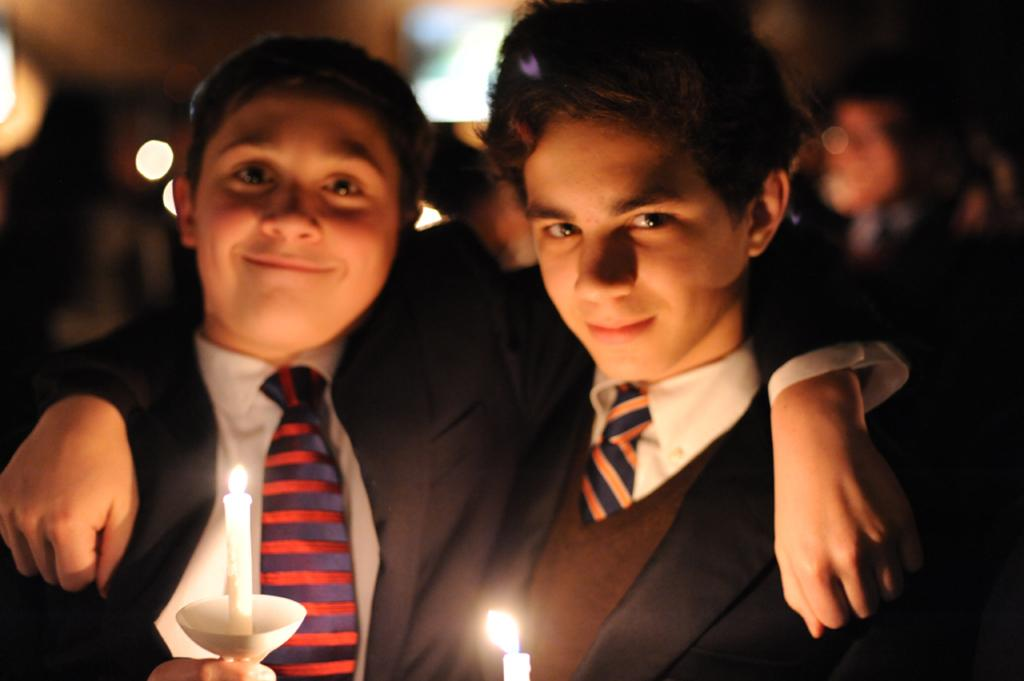How many people are in the image? There are persons in the image, but the exact number is not specified. What are the persons wearing? The persons are wearing clothes. What objects can be seen at the bottom of the image? There are candles at the bottom of the image. What type of education can be seen in the image? There is no indication of education in the image; it only features persons and candles. How many family members are present in the image? The facts do not mention any family members, so it is not possible to determine the number of family members in the image. 